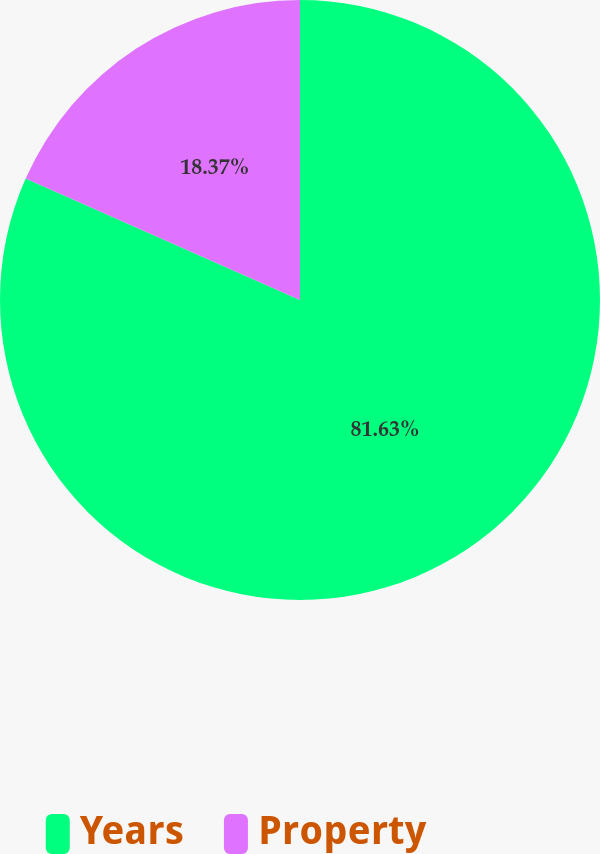<chart> <loc_0><loc_0><loc_500><loc_500><pie_chart><fcel>Years<fcel>Property<nl><fcel>81.63%<fcel>18.37%<nl></chart> 